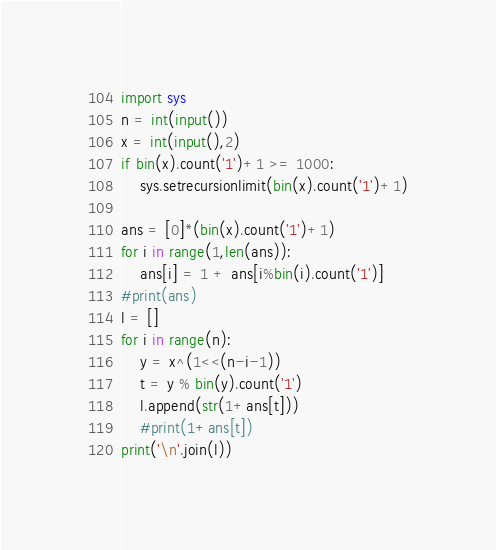<code> <loc_0><loc_0><loc_500><loc_500><_Python_>import sys
n = int(input())
x = int(input(),2)
if bin(x).count('1')+1 >= 1000:
    sys.setrecursionlimit(bin(x).count('1')+1)

ans = [0]*(bin(x).count('1')+1)
for i in range(1,len(ans)):
    ans[i] = 1 + ans[i%bin(i).count('1')]
#print(ans)
l = []
for i in range(n):
    y = x^(1<<(n-i-1))
    t = y % bin(y).count('1')
    l.append(str(1+ans[t]))
    #print(1+ans[t])
print('\n'.join(l))</code> 